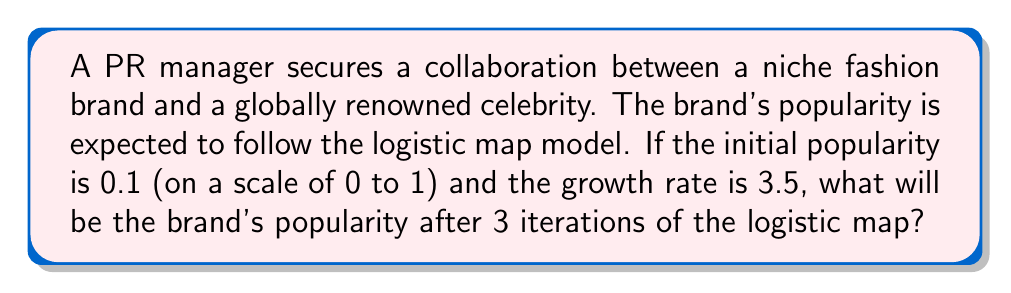Provide a solution to this math problem. The logistic map is given by the equation:

$$x_{n+1} = rx_n(1-x_n)$$

Where:
$x_n$ is the popularity at iteration n
$r$ is the growth rate
$x_0$ is the initial popularity

Given:
$x_0 = 0.1$
$r = 3.5$

Let's calculate the popularity for each iteration:

Iteration 1:
$$x_1 = 3.5 \cdot 0.1 \cdot (1-0.1) = 3.5 \cdot 0.1 \cdot 0.9 = 0.315$$

Iteration 2:
$$x_2 = 3.5 \cdot 0.315 \cdot (1-0.315) = 3.5 \cdot 0.315 \cdot 0.685 = 0.75573375$$

Iteration 3:
$$x_3 = 3.5 \cdot 0.75573375 \cdot (1-0.75573375)$$
$$= 3.5 \cdot 0.75573375 \cdot 0.24426625$$
$$= 0.64631322959375$$

Therefore, after 3 iterations, the brand's popularity will be approximately 0.6463.
Answer: 0.6463 